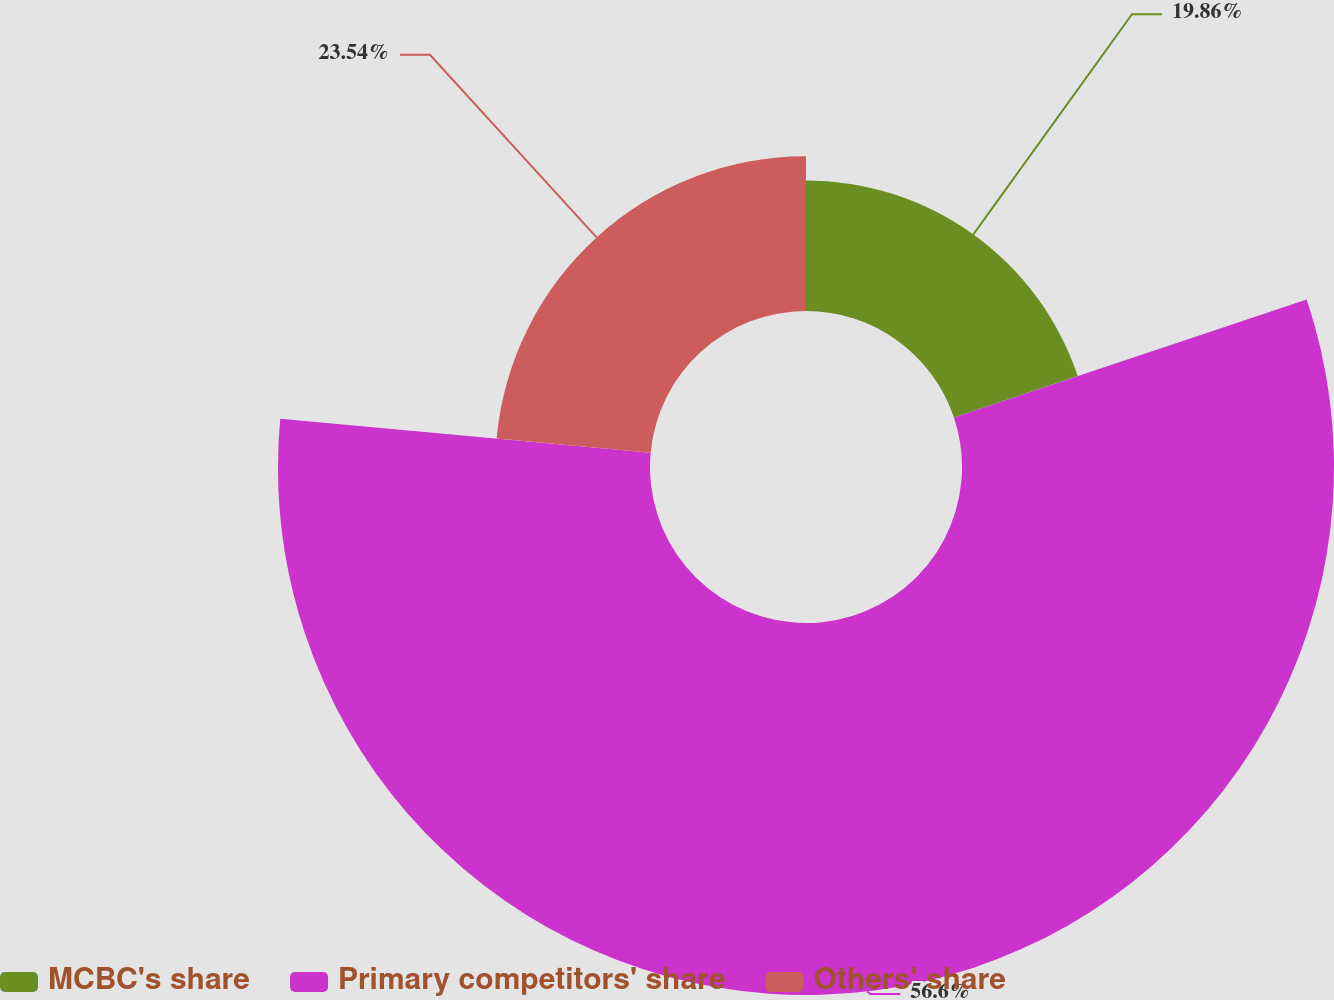Convert chart to OTSL. <chart><loc_0><loc_0><loc_500><loc_500><pie_chart><fcel>MCBC's share<fcel>Primary competitors' share<fcel>Others' share<nl><fcel>19.86%<fcel>56.6%<fcel>23.54%<nl></chart> 